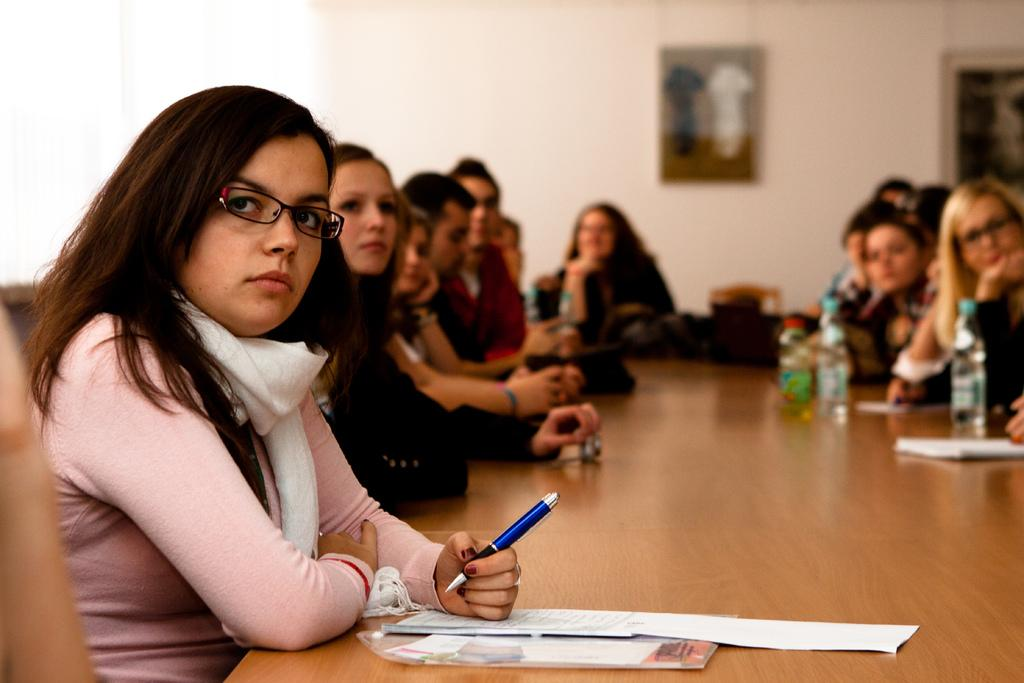What is the main piece of furniture in the image? There is a table in the image. Who is present around the table? A group of women are sitting around the table. What items can be seen on the table are visible? There are water bottles and papers on the table. What can be seen in the background of the image? There is a wall in the background of the image. What type of shirt is the yard wearing in the image? There is no yard or shirt present in the image. 